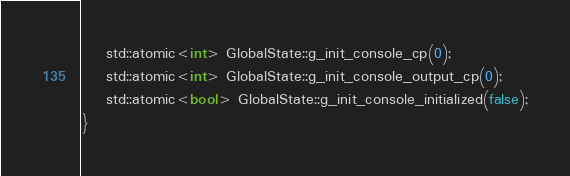<code> <loc_0><loc_0><loc_500><loc_500><_C++_>    std::atomic<int> GlobalState::g_init_console_cp(0);
    std::atomic<int> GlobalState::g_init_console_output_cp(0);
    std::atomic<bool> GlobalState::g_init_console_initialized(false);
}
</code> 